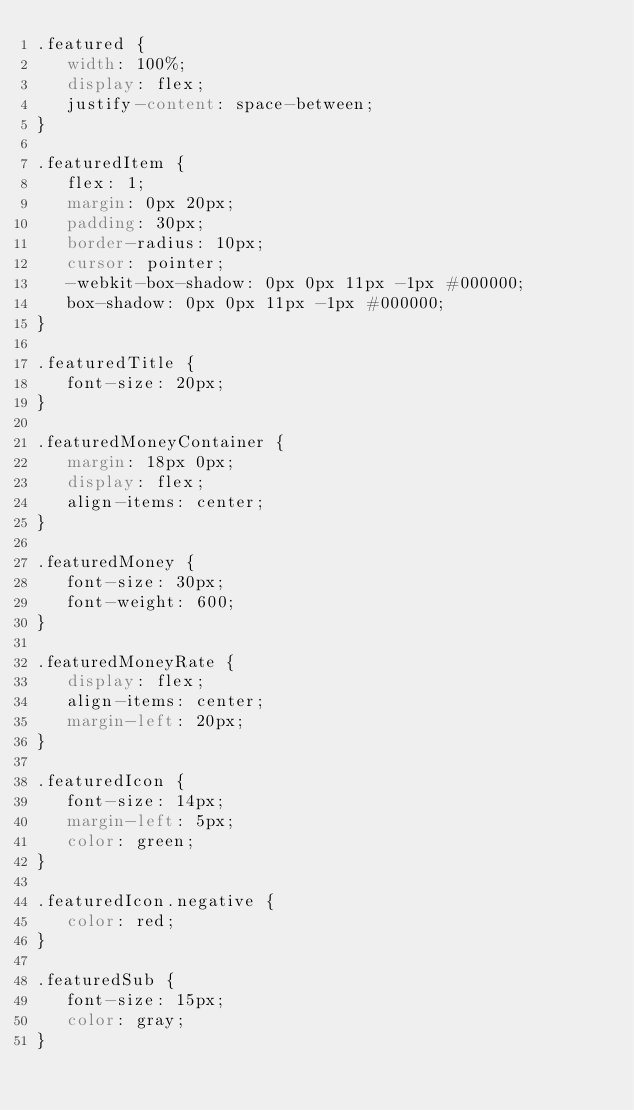Convert code to text. <code><loc_0><loc_0><loc_500><loc_500><_CSS_>.featured {
   width: 100%;
   display: flex;
   justify-content: space-between;
}

.featuredItem {
   flex: 1;
   margin: 0px 20px;
   padding: 30px;
   border-radius: 10px;
   cursor: pointer;
   -webkit-box-shadow: 0px 0px 11px -1px #000000; 
   box-shadow: 0px 0px 11px -1px #000000;
}

.featuredTitle {
   font-size: 20px;
}

.featuredMoneyContainer {
   margin: 18px 0px;
   display: flex;
   align-items: center;
}

.featuredMoney {
   font-size: 30px;
   font-weight: 600;
}

.featuredMoneyRate {
   display: flex;
   align-items: center;
   margin-left: 20px;
}

.featuredIcon {
   font-size: 14px;
   margin-left: 5px;
   color: green;
}

.featuredIcon.negative {
   color: red;
}

.featuredSub {
   font-size: 15px;
   color: gray;
}</code> 